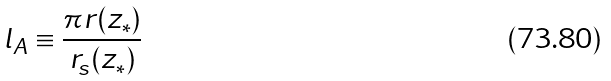<formula> <loc_0><loc_0><loc_500><loc_500>l _ { A } \equiv \frac { \pi r ( z _ { * } ) } { r _ { s } ( z _ { * } ) }</formula> 